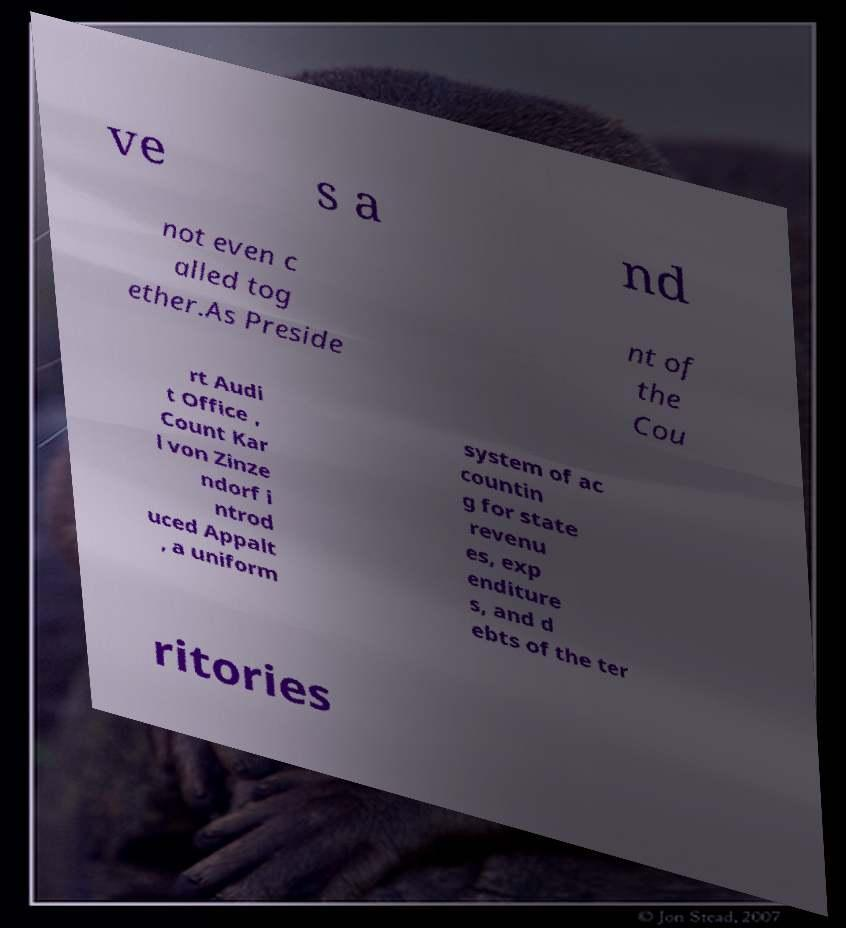There's text embedded in this image that I need extracted. Can you transcribe it verbatim? ve s a nd not even c alled tog ether.As Preside nt of the Cou rt Audi t Office , Count Kar l von Zinze ndorf i ntrod uced Appalt , a uniform system of ac countin g for state revenu es, exp enditure s, and d ebts of the ter ritories 